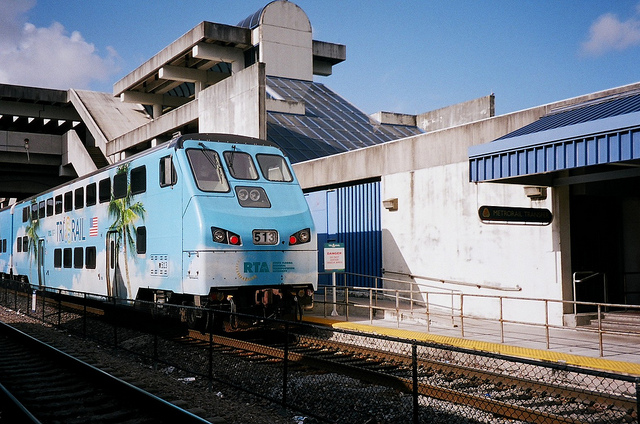<image>Which train station is this? It's unclear which train station this is, it could be RTA or another station. Which train station is this? It is ambiguous which train station is this. It could be RTA or Tropical One. 